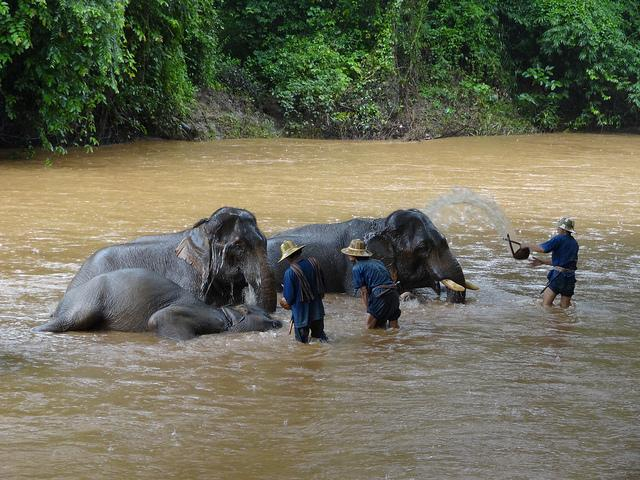What are the people doing to the elephants? washing 